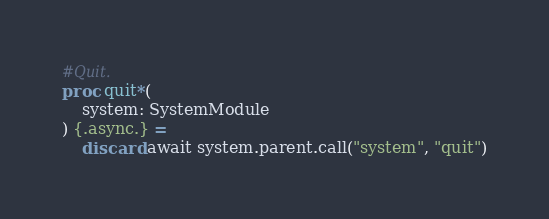<code> <loc_0><loc_0><loc_500><loc_500><_Nim_>#Quit.
proc quit*(
    system: SystemModule
) {.async.} =
    discard await system.parent.call("system", "quit")
</code> 